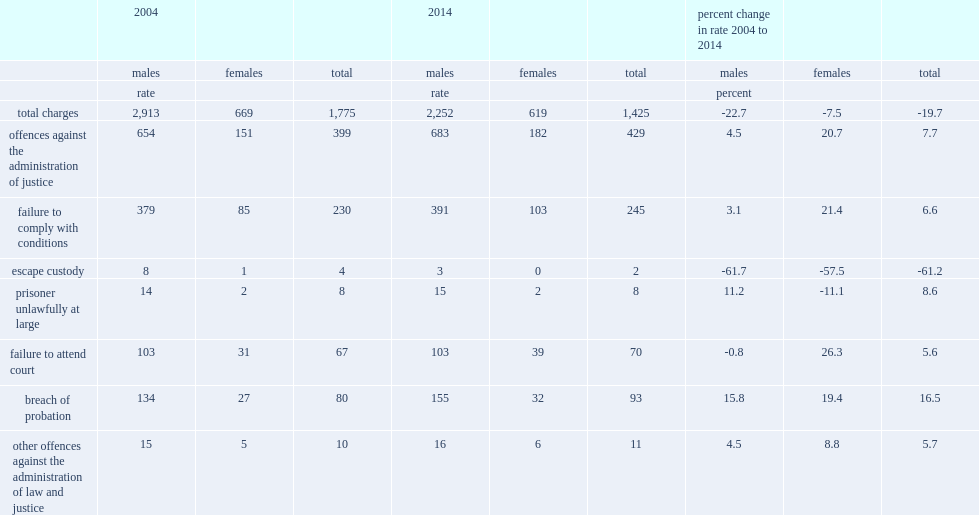What is the change of rate of persons facing charges related to administration of justice offences increased between 2004 and 2014? 7.7. What is the decline of the rate of persons charged in criminal incidents in general has declined between 2004 and 2014? 19.7. What is the change of rate of persons facing charges related to administration of justice offences increased between 2004 and 2014? 7.7. What is the decline of the rate of persons charged in criminal incidents in general has declined between 2004 and 2014? 19.7. 